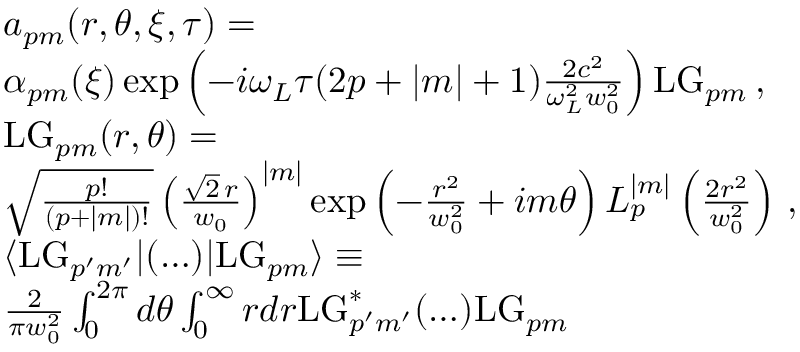Convert formula to latex. <formula><loc_0><loc_0><loc_500><loc_500>\begin{array} { r l } & { a _ { p m } ( r , \theta , \xi , \tau ) = } \\ & { \alpha _ { p m } ( \xi ) \exp \left ( - i \omega _ { L } \tau ( 2 p + | m | + 1 ) \frac { 2 c ^ { 2 } } { \omega _ { L } ^ { 2 } w _ { 0 } ^ { 2 } } \right ) L G _ { p m } \, , } \\ & { L G _ { p m } ( r , \theta ) = } \\ & { \sqrt { \frac { p ! } { ( p + | m | ) ! } } \left ( \frac { \sqrt { 2 } \, r } { w _ { 0 } } \right ) ^ { | m | } \exp \left ( - \frac { r ^ { 2 } } { w _ { 0 } ^ { 2 } } + i m \theta \right ) L _ { p } ^ { | m | } \left ( \frac { 2 r ^ { 2 } } { w _ { 0 } ^ { 2 } } \right ) \, , } \\ & { \langle L G _ { p ^ { \prime } m ^ { \prime } } | ( \dots ) | L G _ { p m } \rangle \equiv } \\ & { \frac { 2 } { \pi w _ { 0 } ^ { 2 } } \int _ { 0 } ^ { 2 \pi } d \theta \int _ { 0 } ^ { \infty } r d r L G _ { p ^ { \prime } m ^ { \prime } } ^ { * } ( \dots ) L G _ { p m } } \end{array}</formula> 